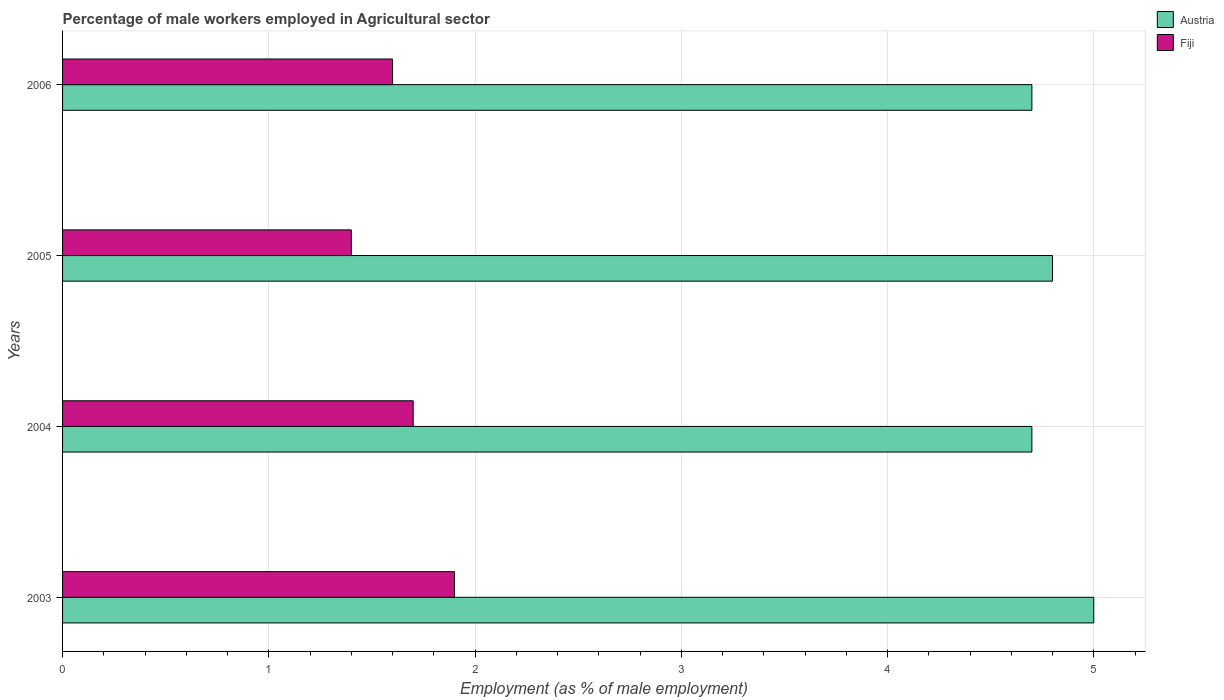How many groups of bars are there?
Ensure brevity in your answer.  4. Are the number of bars per tick equal to the number of legend labels?
Your answer should be very brief. Yes. How many bars are there on the 1st tick from the top?
Your response must be concise. 2. What is the label of the 4th group of bars from the top?
Offer a very short reply. 2003. In how many cases, is the number of bars for a given year not equal to the number of legend labels?
Provide a succinct answer. 0. What is the percentage of male workers employed in Agricultural sector in Fiji in 2006?
Offer a terse response. 1.6. Across all years, what is the minimum percentage of male workers employed in Agricultural sector in Fiji?
Make the answer very short. 1.4. What is the total percentage of male workers employed in Agricultural sector in Fiji in the graph?
Make the answer very short. 6.6. What is the difference between the percentage of male workers employed in Agricultural sector in Austria in 2005 and that in 2006?
Ensure brevity in your answer.  0.1. What is the difference between the percentage of male workers employed in Agricultural sector in Fiji in 2005 and the percentage of male workers employed in Agricultural sector in Austria in 2003?
Your answer should be compact. -3.6. What is the average percentage of male workers employed in Agricultural sector in Austria per year?
Your response must be concise. 4.8. In the year 2004, what is the difference between the percentage of male workers employed in Agricultural sector in Austria and percentage of male workers employed in Agricultural sector in Fiji?
Give a very brief answer. 3. Is the difference between the percentage of male workers employed in Agricultural sector in Austria in 2003 and 2006 greater than the difference between the percentage of male workers employed in Agricultural sector in Fiji in 2003 and 2006?
Ensure brevity in your answer.  Yes. What is the difference between the highest and the second highest percentage of male workers employed in Agricultural sector in Austria?
Give a very brief answer. 0.2. What is the difference between the highest and the lowest percentage of male workers employed in Agricultural sector in Fiji?
Keep it short and to the point. 0.5. Is the sum of the percentage of male workers employed in Agricultural sector in Austria in 2005 and 2006 greater than the maximum percentage of male workers employed in Agricultural sector in Fiji across all years?
Your response must be concise. Yes. What does the 1st bar from the bottom in 2006 represents?
Provide a succinct answer. Austria. How many bars are there?
Your answer should be very brief. 8. What is the difference between two consecutive major ticks on the X-axis?
Offer a very short reply. 1. How many legend labels are there?
Offer a very short reply. 2. What is the title of the graph?
Your answer should be compact. Percentage of male workers employed in Agricultural sector. What is the label or title of the X-axis?
Your answer should be compact. Employment (as % of male employment). What is the label or title of the Y-axis?
Your answer should be compact. Years. What is the Employment (as % of male employment) of Austria in 2003?
Your answer should be compact. 5. What is the Employment (as % of male employment) of Fiji in 2003?
Your answer should be very brief. 1.9. What is the Employment (as % of male employment) in Austria in 2004?
Provide a succinct answer. 4.7. What is the Employment (as % of male employment) of Fiji in 2004?
Keep it short and to the point. 1.7. What is the Employment (as % of male employment) in Austria in 2005?
Provide a short and direct response. 4.8. What is the Employment (as % of male employment) of Fiji in 2005?
Provide a succinct answer. 1.4. What is the Employment (as % of male employment) of Austria in 2006?
Give a very brief answer. 4.7. What is the Employment (as % of male employment) in Fiji in 2006?
Give a very brief answer. 1.6. Across all years, what is the maximum Employment (as % of male employment) of Austria?
Offer a very short reply. 5. Across all years, what is the maximum Employment (as % of male employment) of Fiji?
Make the answer very short. 1.9. Across all years, what is the minimum Employment (as % of male employment) of Austria?
Your response must be concise. 4.7. Across all years, what is the minimum Employment (as % of male employment) in Fiji?
Provide a succinct answer. 1.4. What is the difference between the Employment (as % of male employment) in Fiji in 2003 and that in 2004?
Make the answer very short. 0.2. What is the difference between the Employment (as % of male employment) of Austria in 2003 and that in 2005?
Offer a very short reply. 0.2. What is the difference between the Employment (as % of male employment) of Fiji in 2003 and that in 2005?
Make the answer very short. 0.5. What is the difference between the Employment (as % of male employment) in Fiji in 2003 and that in 2006?
Offer a terse response. 0.3. What is the difference between the Employment (as % of male employment) of Austria in 2004 and that in 2005?
Your response must be concise. -0.1. What is the difference between the Employment (as % of male employment) in Fiji in 2004 and that in 2006?
Your response must be concise. 0.1. What is the difference between the Employment (as % of male employment) of Austria in 2003 and the Employment (as % of male employment) of Fiji in 2004?
Provide a succinct answer. 3.3. What is the difference between the Employment (as % of male employment) in Austria in 2003 and the Employment (as % of male employment) in Fiji in 2006?
Provide a short and direct response. 3.4. What is the difference between the Employment (as % of male employment) in Austria in 2005 and the Employment (as % of male employment) in Fiji in 2006?
Offer a very short reply. 3.2. What is the average Employment (as % of male employment) in Fiji per year?
Provide a succinct answer. 1.65. In the year 2004, what is the difference between the Employment (as % of male employment) in Austria and Employment (as % of male employment) in Fiji?
Your answer should be compact. 3. What is the ratio of the Employment (as % of male employment) in Austria in 2003 to that in 2004?
Give a very brief answer. 1.06. What is the ratio of the Employment (as % of male employment) in Fiji in 2003 to that in 2004?
Ensure brevity in your answer.  1.12. What is the ratio of the Employment (as % of male employment) of Austria in 2003 to that in 2005?
Your answer should be very brief. 1.04. What is the ratio of the Employment (as % of male employment) of Fiji in 2003 to that in 2005?
Offer a terse response. 1.36. What is the ratio of the Employment (as % of male employment) of Austria in 2003 to that in 2006?
Your answer should be compact. 1.06. What is the ratio of the Employment (as % of male employment) in Fiji in 2003 to that in 2006?
Make the answer very short. 1.19. What is the ratio of the Employment (as % of male employment) of Austria in 2004 to that in 2005?
Your answer should be very brief. 0.98. What is the ratio of the Employment (as % of male employment) of Fiji in 2004 to that in 2005?
Keep it short and to the point. 1.21. What is the ratio of the Employment (as % of male employment) of Austria in 2004 to that in 2006?
Keep it short and to the point. 1. What is the ratio of the Employment (as % of male employment) in Austria in 2005 to that in 2006?
Provide a short and direct response. 1.02. What is the difference between the highest and the second highest Employment (as % of male employment) of Fiji?
Ensure brevity in your answer.  0.2. What is the difference between the highest and the lowest Employment (as % of male employment) in Fiji?
Make the answer very short. 0.5. 